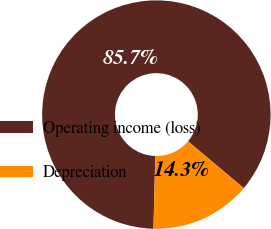Convert chart to OTSL. <chart><loc_0><loc_0><loc_500><loc_500><pie_chart><fcel>Operating income (loss)<fcel>Depreciation<nl><fcel>85.73%<fcel>14.27%<nl></chart> 